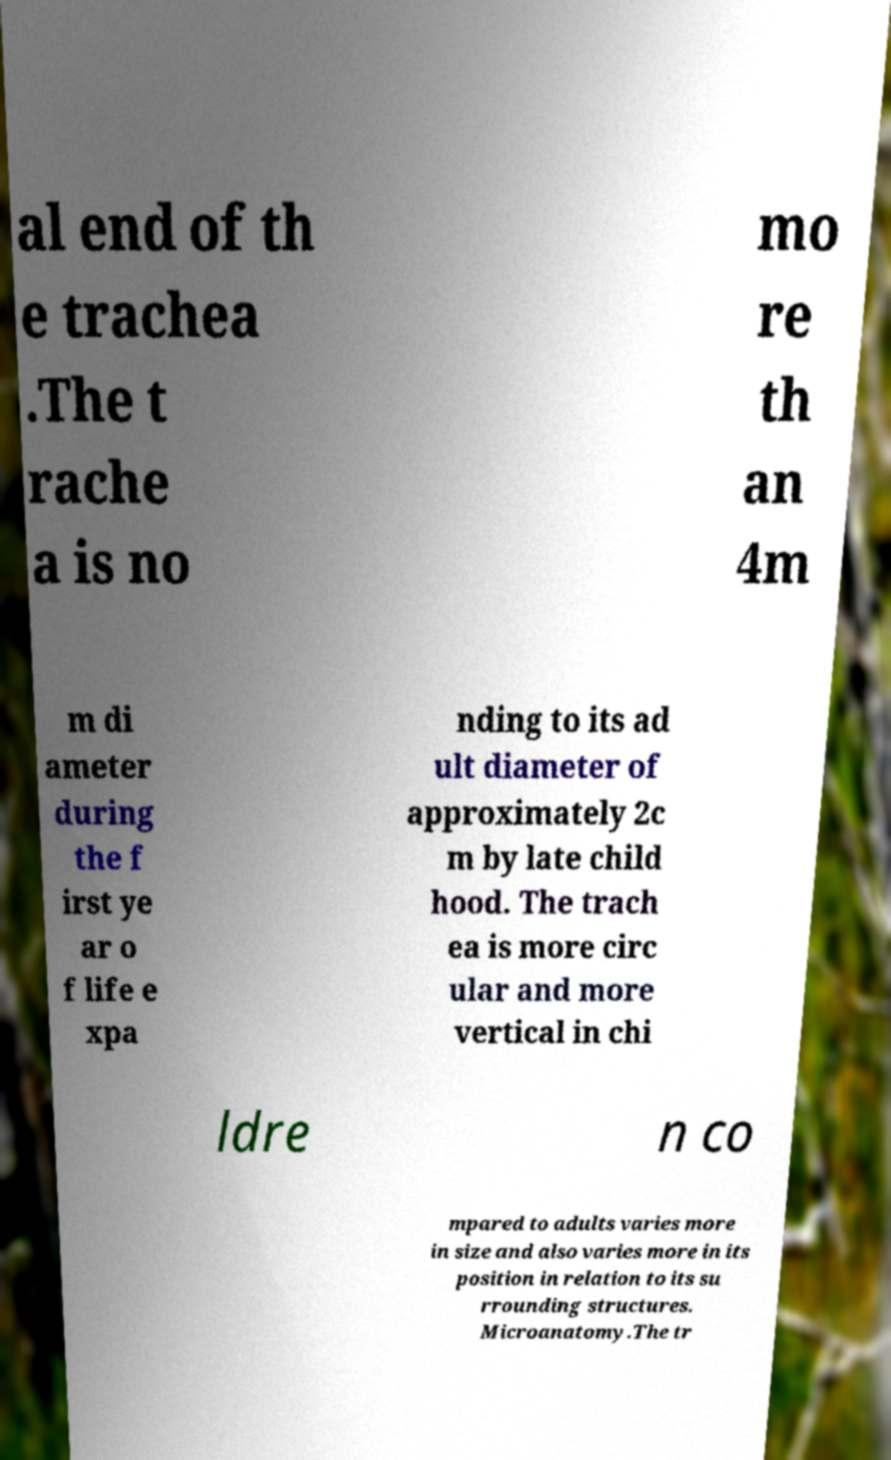There's text embedded in this image that I need extracted. Can you transcribe it verbatim? al end of th e trachea .The t rache a is no mo re th an 4m m di ameter during the f irst ye ar o f life e xpa nding to its ad ult diameter of approximately 2c m by late child hood. The trach ea is more circ ular and more vertical in chi ldre n co mpared to adults varies more in size and also varies more in its position in relation to its su rrounding structures. Microanatomy.The tr 